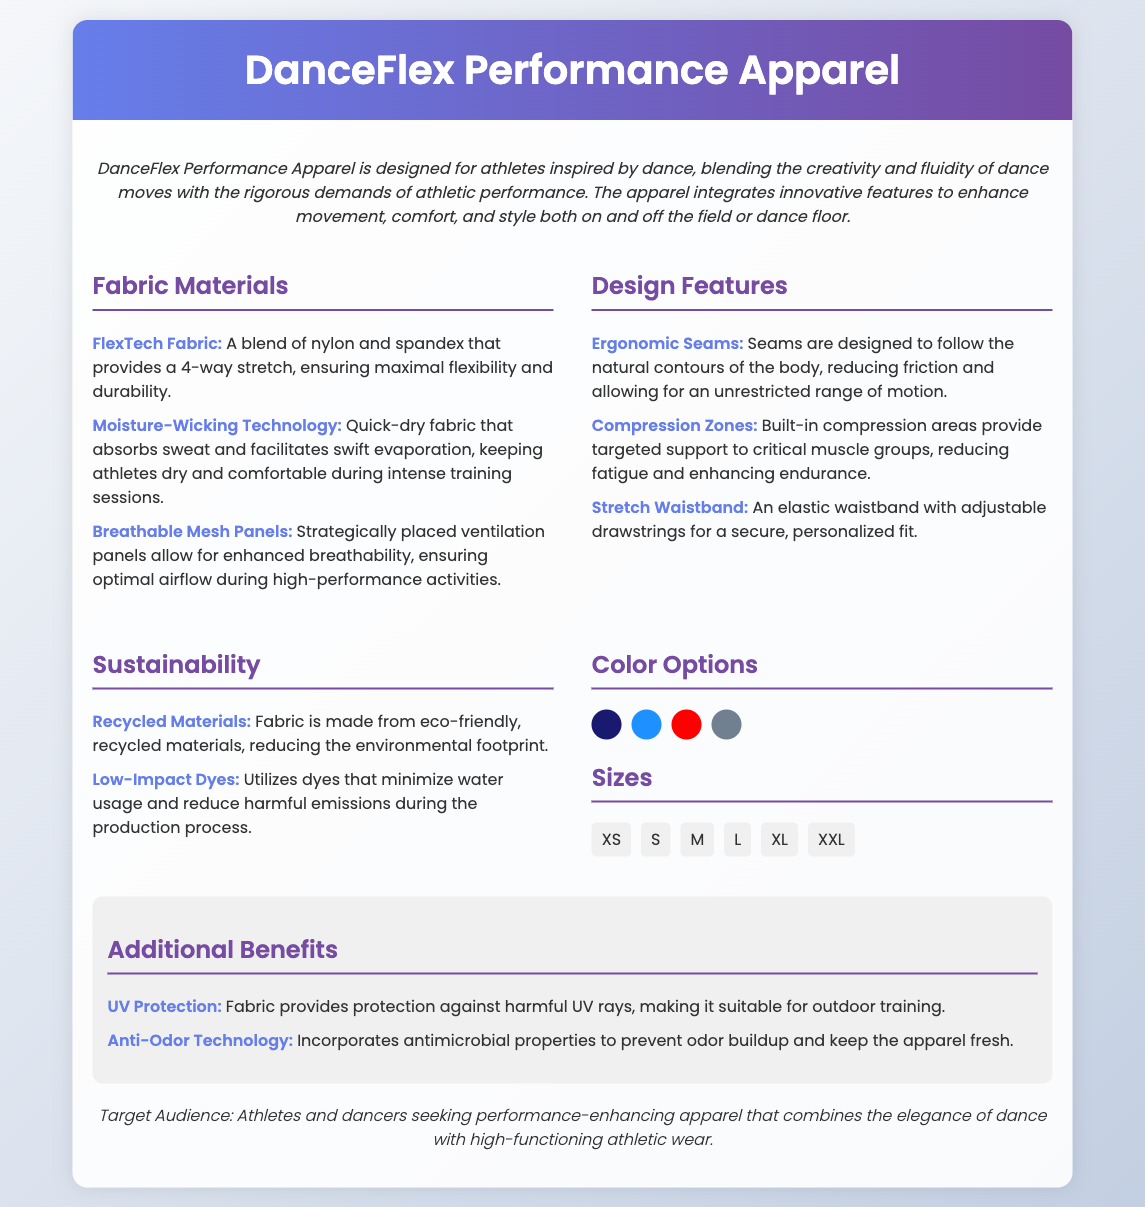what is the name of the apparel? The name of the apparel is given in the document's header, which states "DanceFlex Performance Apparel."
Answer: DanceFlex Performance Apparel what materials are used in FlexTech Fabric? The document specifies the materials used in FlexTech Fabric, which are nylon and spandex.
Answer: nylon and spandex how many color options are available? The document lists four color options shown in the color options section.
Answer: 4 what feature reduces odor buildup? The document mentions a feature that specifically prevents odor buildup, highlighted as "Anti-Odor Technology."
Answer: Anti-Odor Technology what is the size range available for the apparel? The document outlines the size range available by listing sizes, which include XS, S, M, L, XL, and XXL.
Answer: XS, S, M, L, XL, XXL what sustainability feature involves dyes? The document indicates a sustainability feature that refers to the use of dyes, which is "Low-Impact Dyes."
Answer: Low-Impact Dyes what is the primary target audience? The document specifies the target audience in the final section, describing them as "Athletes and dancers."
Answer: Athletes and dancers how does the fabric benefit outdoor training? The document specifies a feature that offers protection beneficial for outdoor training, namely "UV Protection."
Answer: UV Protection 